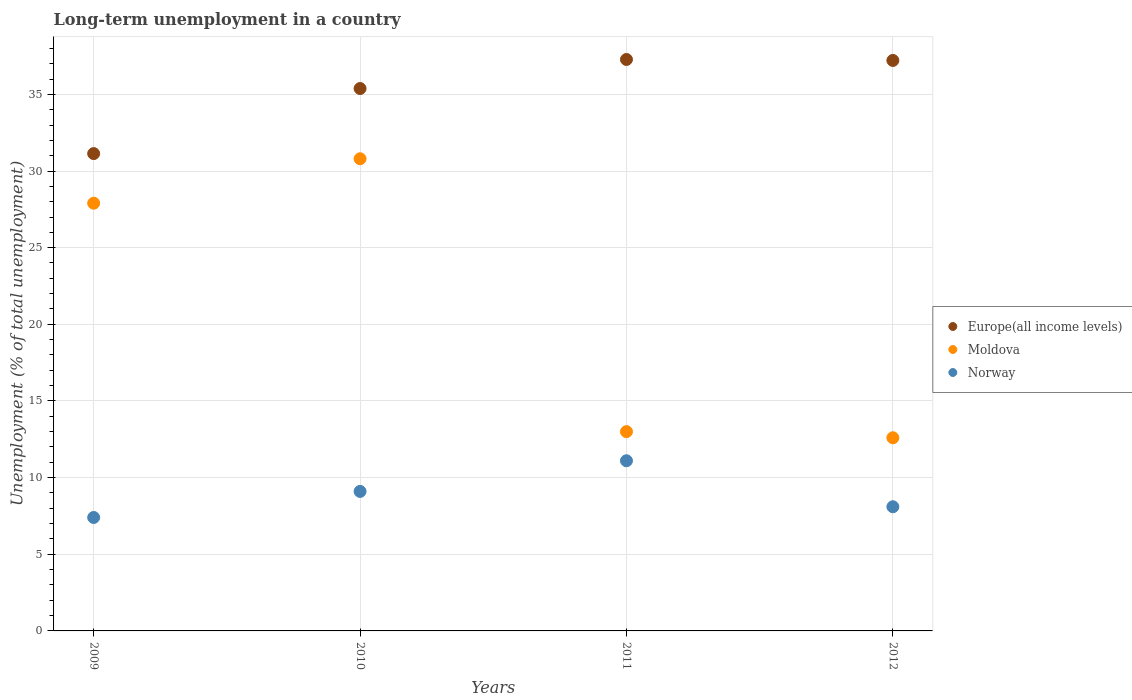What is the percentage of long-term unemployed population in Moldova in 2009?
Your response must be concise. 27.9. Across all years, what is the maximum percentage of long-term unemployed population in Norway?
Your answer should be very brief. 11.1. Across all years, what is the minimum percentage of long-term unemployed population in Moldova?
Keep it short and to the point. 12.6. In which year was the percentage of long-term unemployed population in Europe(all income levels) minimum?
Keep it short and to the point. 2009. What is the total percentage of long-term unemployed population in Moldova in the graph?
Give a very brief answer. 84.3. What is the difference between the percentage of long-term unemployed population in Norway in 2010 and that in 2011?
Your response must be concise. -2. What is the difference between the percentage of long-term unemployed population in Norway in 2011 and the percentage of long-term unemployed population in Moldova in 2009?
Offer a terse response. -16.8. What is the average percentage of long-term unemployed population in Europe(all income levels) per year?
Give a very brief answer. 35.25. In the year 2012, what is the difference between the percentage of long-term unemployed population in Europe(all income levels) and percentage of long-term unemployed population in Norway?
Offer a terse response. 29.11. What is the ratio of the percentage of long-term unemployed population in Moldova in 2009 to that in 2011?
Ensure brevity in your answer.  2.15. What is the difference between the highest and the second highest percentage of long-term unemployed population in Europe(all income levels)?
Give a very brief answer. 0.06. What is the difference between the highest and the lowest percentage of long-term unemployed population in Moldova?
Offer a terse response. 18.2. Does the percentage of long-term unemployed population in Norway monotonically increase over the years?
Make the answer very short. No. Is the percentage of long-term unemployed population in Norway strictly greater than the percentage of long-term unemployed population in Europe(all income levels) over the years?
Keep it short and to the point. No. How many dotlines are there?
Ensure brevity in your answer.  3. How many years are there in the graph?
Provide a succinct answer. 4. Are the values on the major ticks of Y-axis written in scientific E-notation?
Make the answer very short. No. Does the graph contain any zero values?
Your answer should be very brief. No. What is the title of the graph?
Make the answer very short. Long-term unemployment in a country. Does "Zimbabwe" appear as one of the legend labels in the graph?
Offer a very short reply. No. What is the label or title of the X-axis?
Your answer should be compact. Years. What is the label or title of the Y-axis?
Ensure brevity in your answer.  Unemployment (% of total unemployment). What is the Unemployment (% of total unemployment) in Europe(all income levels) in 2009?
Ensure brevity in your answer.  31.14. What is the Unemployment (% of total unemployment) of Moldova in 2009?
Give a very brief answer. 27.9. What is the Unemployment (% of total unemployment) of Norway in 2009?
Provide a succinct answer. 7.4. What is the Unemployment (% of total unemployment) of Europe(all income levels) in 2010?
Offer a terse response. 35.38. What is the Unemployment (% of total unemployment) in Moldova in 2010?
Your response must be concise. 30.8. What is the Unemployment (% of total unemployment) in Norway in 2010?
Ensure brevity in your answer.  9.1. What is the Unemployment (% of total unemployment) in Europe(all income levels) in 2011?
Your answer should be compact. 37.28. What is the Unemployment (% of total unemployment) in Moldova in 2011?
Make the answer very short. 13. What is the Unemployment (% of total unemployment) in Norway in 2011?
Make the answer very short. 11.1. What is the Unemployment (% of total unemployment) in Europe(all income levels) in 2012?
Your response must be concise. 37.21. What is the Unemployment (% of total unemployment) in Moldova in 2012?
Keep it short and to the point. 12.6. What is the Unemployment (% of total unemployment) of Norway in 2012?
Your response must be concise. 8.1. Across all years, what is the maximum Unemployment (% of total unemployment) of Europe(all income levels)?
Your answer should be compact. 37.28. Across all years, what is the maximum Unemployment (% of total unemployment) in Moldova?
Your answer should be very brief. 30.8. Across all years, what is the maximum Unemployment (% of total unemployment) of Norway?
Give a very brief answer. 11.1. Across all years, what is the minimum Unemployment (% of total unemployment) of Europe(all income levels)?
Keep it short and to the point. 31.14. Across all years, what is the minimum Unemployment (% of total unemployment) in Moldova?
Ensure brevity in your answer.  12.6. Across all years, what is the minimum Unemployment (% of total unemployment) in Norway?
Give a very brief answer. 7.4. What is the total Unemployment (% of total unemployment) in Europe(all income levels) in the graph?
Make the answer very short. 141.01. What is the total Unemployment (% of total unemployment) in Moldova in the graph?
Ensure brevity in your answer.  84.3. What is the total Unemployment (% of total unemployment) in Norway in the graph?
Offer a terse response. 35.7. What is the difference between the Unemployment (% of total unemployment) of Europe(all income levels) in 2009 and that in 2010?
Keep it short and to the point. -4.24. What is the difference between the Unemployment (% of total unemployment) in Norway in 2009 and that in 2010?
Provide a short and direct response. -1.7. What is the difference between the Unemployment (% of total unemployment) in Europe(all income levels) in 2009 and that in 2011?
Provide a succinct answer. -6.14. What is the difference between the Unemployment (% of total unemployment) of Moldova in 2009 and that in 2011?
Your answer should be very brief. 14.9. What is the difference between the Unemployment (% of total unemployment) in Europe(all income levels) in 2009 and that in 2012?
Ensure brevity in your answer.  -6.08. What is the difference between the Unemployment (% of total unemployment) in Europe(all income levels) in 2010 and that in 2011?
Ensure brevity in your answer.  -1.89. What is the difference between the Unemployment (% of total unemployment) of Norway in 2010 and that in 2011?
Keep it short and to the point. -2. What is the difference between the Unemployment (% of total unemployment) of Europe(all income levels) in 2010 and that in 2012?
Keep it short and to the point. -1.83. What is the difference between the Unemployment (% of total unemployment) in Norway in 2010 and that in 2012?
Ensure brevity in your answer.  1. What is the difference between the Unemployment (% of total unemployment) of Europe(all income levels) in 2011 and that in 2012?
Your answer should be compact. 0.06. What is the difference between the Unemployment (% of total unemployment) of Moldova in 2011 and that in 2012?
Give a very brief answer. 0.4. What is the difference between the Unemployment (% of total unemployment) of Norway in 2011 and that in 2012?
Offer a terse response. 3. What is the difference between the Unemployment (% of total unemployment) of Europe(all income levels) in 2009 and the Unemployment (% of total unemployment) of Moldova in 2010?
Give a very brief answer. 0.34. What is the difference between the Unemployment (% of total unemployment) of Europe(all income levels) in 2009 and the Unemployment (% of total unemployment) of Norway in 2010?
Provide a short and direct response. 22.04. What is the difference between the Unemployment (% of total unemployment) in Moldova in 2009 and the Unemployment (% of total unemployment) in Norway in 2010?
Provide a short and direct response. 18.8. What is the difference between the Unemployment (% of total unemployment) in Europe(all income levels) in 2009 and the Unemployment (% of total unemployment) in Moldova in 2011?
Provide a short and direct response. 18.14. What is the difference between the Unemployment (% of total unemployment) in Europe(all income levels) in 2009 and the Unemployment (% of total unemployment) in Norway in 2011?
Offer a very short reply. 20.04. What is the difference between the Unemployment (% of total unemployment) of Moldova in 2009 and the Unemployment (% of total unemployment) of Norway in 2011?
Offer a terse response. 16.8. What is the difference between the Unemployment (% of total unemployment) of Europe(all income levels) in 2009 and the Unemployment (% of total unemployment) of Moldova in 2012?
Make the answer very short. 18.54. What is the difference between the Unemployment (% of total unemployment) of Europe(all income levels) in 2009 and the Unemployment (% of total unemployment) of Norway in 2012?
Offer a terse response. 23.04. What is the difference between the Unemployment (% of total unemployment) in Moldova in 2009 and the Unemployment (% of total unemployment) in Norway in 2012?
Ensure brevity in your answer.  19.8. What is the difference between the Unemployment (% of total unemployment) of Europe(all income levels) in 2010 and the Unemployment (% of total unemployment) of Moldova in 2011?
Offer a terse response. 22.38. What is the difference between the Unemployment (% of total unemployment) in Europe(all income levels) in 2010 and the Unemployment (% of total unemployment) in Norway in 2011?
Make the answer very short. 24.28. What is the difference between the Unemployment (% of total unemployment) of Europe(all income levels) in 2010 and the Unemployment (% of total unemployment) of Moldova in 2012?
Make the answer very short. 22.78. What is the difference between the Unemployment (% of total unemployment) in Europe(all income levels) in 2010 and the Unemployment (% of total unemployment) in Norway in 2012?
Make the answer very short. 27.28. What is the difference between the Unemployment (% of total unemployment) in Moldova in 2010 and the Unemployment (% of total unemployment) in Norway in 2012?
Your answer should be very brief. 22.7. What is the difference between the Unemployment (% of total unemployment) of Europe(all income levels) in 2011 and the Unemployment (% of total unemployment) of Moldova in 2012?
Your response must be concise. 24.68. What is the difference between the Unemployment (% of total unemployment) in Europe(all income levels) in 2011 and the Unemployment (% of total unemployment) in Norway in 2012?
Your answer should be compact. 29.18. What is the average Unemployment (% of total unemployment) of Europe(all income levels) per year?
Your answer should be compact. 35.25. What is the average Unemployment (% of total unemployment) in Moldova per year?
Your answer should be compact. 21.07. What is the average Unemployment (% of total unemployment) of Norway per year?
Make the answer very short. 8.93. In the year 2009, what is the difference between the Unemployment (% of total unemployment) in Europe(all income levels) and Unemployment (% of total unemployment) in Moldova?
Give a very brief answer. 3.24. In the year 2009, what is the difference between the Unemployment (% of total unemployment) of Europe(all income levels) and Unemployment (% of total unemployment) of Norway?
Give a very brief answer. 23.74. In the year 2009, what is the difference between the Unemployment (% of total unemployment) in Moldova and Unemployment (% of total unemployment) in Norway?
Make the answer very short. 20.5. In the year 2010, what is the difference between the Unemployment (% of total unemployment) of Europe(all income levels) and Unemployment (% of total unemployment) of Moldova?
Provide a succinct answer. 4.58. In the year 2010, what is the difference between the Unemployment (% of total unemployment) in Europe(all income levels) and Unemployment (% of total unemployment) in Norway?
Give a very brief answer. 26.28. In the year 2010, what is the difference between the Unemployment (% of total unemployment) of Moldova and Unemployment (% of total unemployment) of Norway?
Give a very brief answer. 21.7. In the year 2011, what is the difference between the Unemployment (% of total unemployment) in Europe(all income levels) and Unemployment (% of total unemployment) in Moldova?
Offer a very short reply. 24.28. In the year 2011, what is the difference between the Unemployment (% of total unemployment) of Europe(all income levels) and Unemployment (% of total unemployment) of Norway?
Your response must be concise. 26.18. In the year 2012, what is the difference between the Unemployment (% of total unemployment) in Europe(all income levels) and Unemployment (% of total unemployment) in Moldova?
Your answer should be compact. 24.61. In the year 2012, what is the difference between the Unemployment (% of total unemployment) of Europe(all income levels) and Unemployment (% of total unemployment) of Norway?
Your response must be concise. 29.11. In the year 2012, what is the difference between the Unemployment (% of total unemployment) in Moldova and Unemployment (% of total unemployment) in Norway?
Your answer should be very brief. 4.5. What is the ratio of the Unemployment (% of total unemployment) of Moldova in 2009 to that in 2010?
Give a very brief answer. 0.91. What is the ratio of the Unemployment (% of total unemployment) in Norway in 2009 to that in 2010?
Provide a short and direct response. 0.81. What is the ratio of the Unemployment (% of total unemployment) of Europe(all income levels) in 2009 to that in 2011?
Offer a very short reply. 0.84. What is the ratio of the Unemployment (% of total unemployment) in Moldova in 2009 to that in 2011?
Your response must be concise. 2.15. What is the ratio of the Unemployment (% of total unemployment) of Norway in 2009 to that in 2011?
Provide a succinct answer. 0.67. What is the ratio of the Unemployment (% of total unemployment) of Europe(all income levels) in 2009 to that in 2012?
Make the answer very short. 0.84. What is the ratio of the Unemployment (% of total unemployment) in Moldova in 2009 to that in 2012?
Ensure brevity in your answer.  2.21. What is the ratio of the Unemployment (% of total unemployment) of Norway in 2009 to that in 2012?
Your answer should be compact. 0.91. What is the ratio of the Unemployment (% of total unemployment) in Europe(all income levels) in 2010 to that in 2011?
Provide a short and direct response. 0.95. What is the ratio of the Unemployment (% of total unemployment) in Moldova in 2010 to that in 2011?
Ensure brevity in your answer.  2.37. What is the ratio of the Unemployment (% of total unemployment) of Norway in 2010 to that in 2011?
Give a very brief answer. 0.82. What is the ratio of the Unemployment (% of total unemployment) in Europe(all income levels) in 2010 to that in 2012?
Make the answer very short. 0.95. What is the ratio of the Unemployment (% of total unemployment) of Moldova in 2010 to that in 2012?
Your answer should be very brief. 2.44. What is the ratio of the Unemployment (% of total unemployment) of Norway in 2010 to that in 2012?
Your answer should be very brief. 1.12. What is the ratio of the Unemployment (% of total unemployment) in Europe(all income levels) in 2011 to that in 2012?
Offer a terse response. 1. What is the ratio of the Unemployment (% of total unemployment) in Moldova in 2011 to that in 2012?
Your answer should be compact. 1.03. What is the ratio of the Unemployment (% of total unemployment) in Norway in 2011 to that in 2012?
Your answer should be very brief. 1.37. What is the difference between the highest and the second highest Unemployment (% of total unemployment) of Europe(all income levels)?
Ensure brevity in your answer.  0.06. What is the difference between the highest and the lowest Unemployment (% of total unemployment) of Europe(all income levels)?
Ensure brevity in your answer.  6.14. What is the difference between the highest and the lowest Unemployment (% of total unemployment) of Moldova?
Give a very brief answer. 18.2. What is the difference between the highest and the lowest Unemployment (% of total unemployment) of Norway?
Make the answer very short. 3.7. 